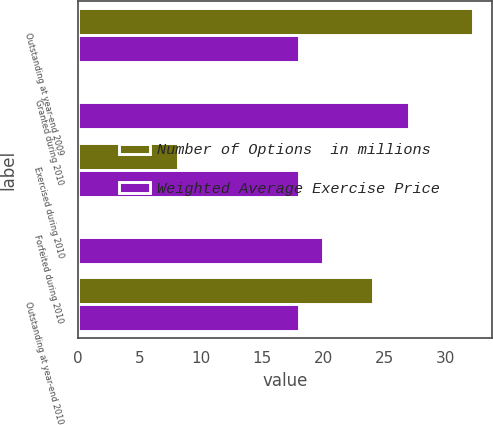Convert chart. <chart><loc_0><loc_0><loc_500><loc_500><stacked_bar_chart><ecel><fcel>Outstanding at year-end 2009<fcel>Granted during 2010<fcel>Exercised during 2010<fcel>Forfeited during 2010<fcel>Outstanding at year-end 2010<nl><fcel>Number of Options  in millions<fcel>32.2<fcel>0.1<fcel>8.2<fcel>0<fcel>24.1<nl><fcel>Weighted Average Exercise Price<fcel>18<fcel>27<fcel>18<fcel>20<fcel>18<nl></chart> 